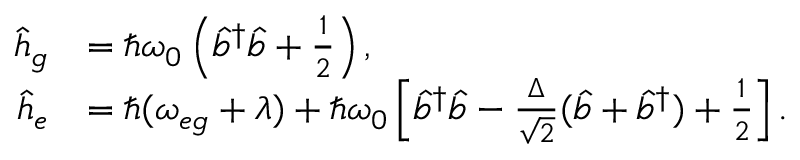Convert formula to latex. <formula><loc_0><loc_0><loc_500><loc_500>\begin{array} { r l } { \hat { h } _ { g } } & { = \hbar { \omega } _ { 0 } \left ( \hat { b } ^ { \dagger } \hat { b } + \frac { 1 } { 2 } \right ) , } \\ { \hat { h } _ { e } } & { = \hbar { ( } \omega _ { e g } + \lambda ) + \hbar { \omega } _ { 0 } \left [ \hat { b } ^ { \dagger } \hat { b } - \frac { \Delta } { \sqrt { 2 } } ( \hat { b } + \hat { b } ^ { \dagger } ) + \frac { 1 } { 2 } \right ] . } \end{array}</formula> 